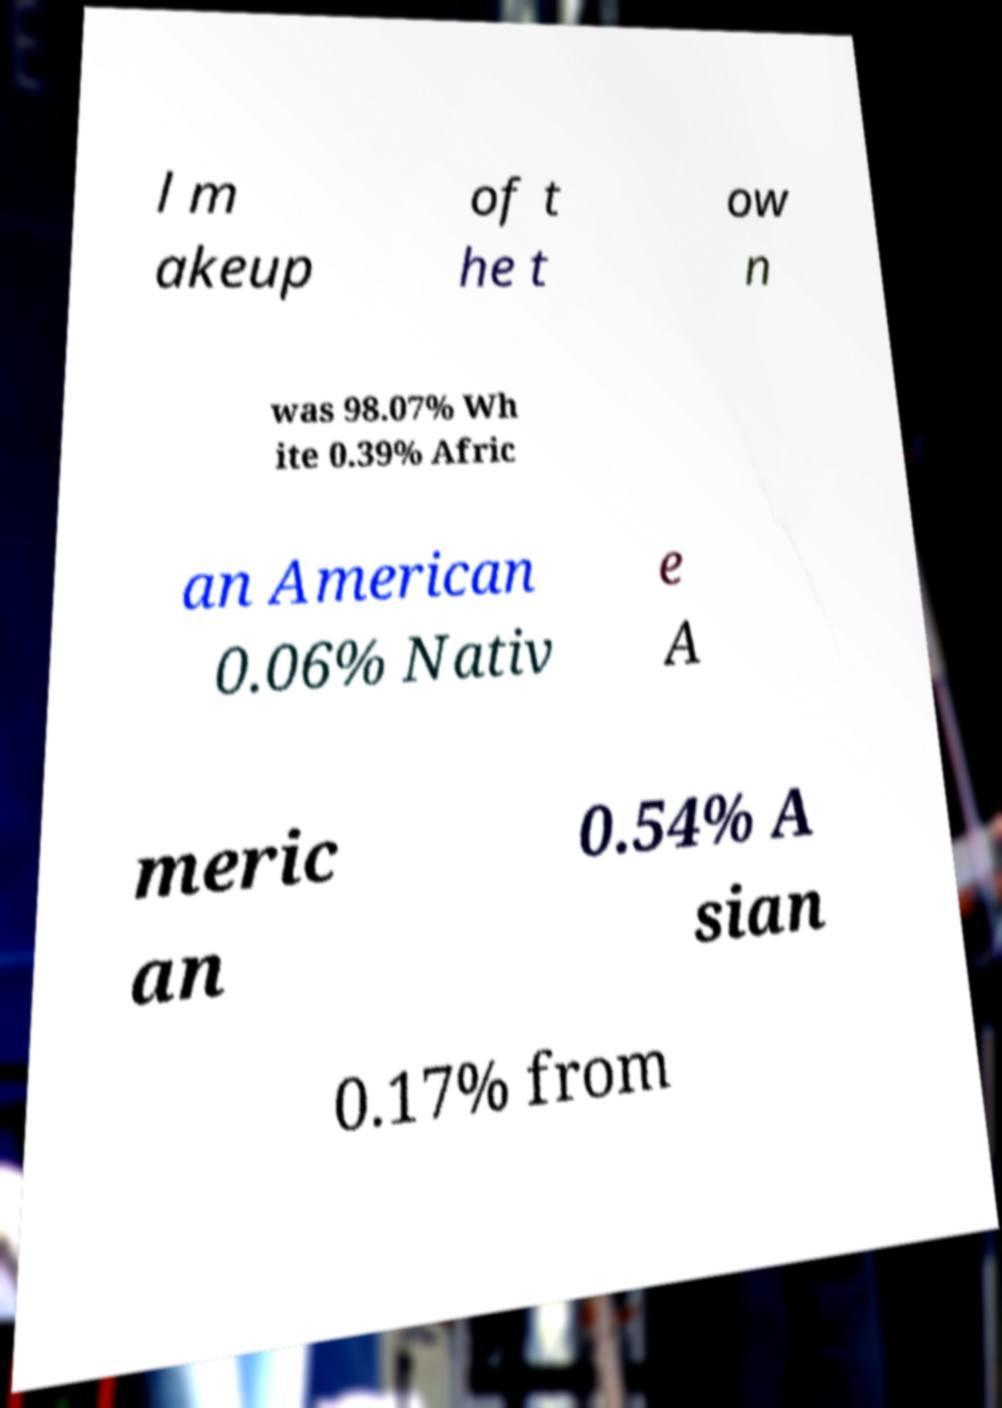Please identify and transcribe the text found in this image. l m akeup of t he t ow n was 98.07% Wh ite 0.39% Afric an American 0.06% Nativ e A meric an 0.54% A sian 0.17% from 